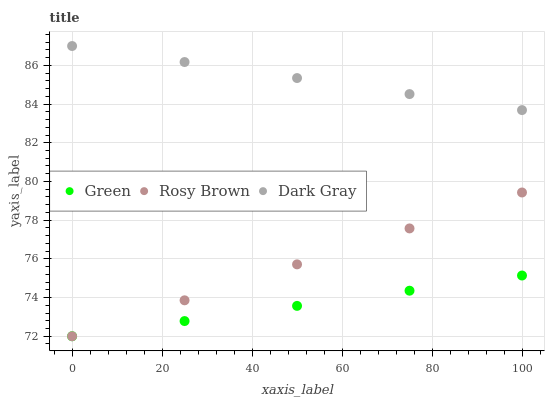Does Green have the minimum area under the curve?
Answer yes or no. Yes. Does Dark Gray have the maximum area under the curve?
Answer yes or no. Yes. Does Rosy Brown have the minimum area under the curve?
Answer yes or no. No. Does Rosy Brown have the maximum area under the curve?
Answer yes or no. No. Is Dark Gray the smoothest?
Answer yes or no. Yes. Is Rosy Brown the roughest?
Answer yes or no. Yes. Is Rosy Brown the smoothest?
Answer yes or no. No. Is Green the roughest?
Answer yes or no. No. Does Rosy Brown have the lowest value?
Answer yes or no. Yes. Does Dark Gray have the highest value?
Answer yes or no. Yes. Does Rosy Brown have the highest value?
Answer yes or no. No. Is Green less than Dark Gray?
Answer yes or no. Yes. Is Dark Gray greater than Green?
Answer yes or no. Yes. Does Rosy Brown intersect Green?
Answer yes or no. Yes. Is Rosy Brown less than Green?
Answer yes or no. No. Is Rosy Brown greater than Green?
Answer yes or no. No. Does Green intersect Dark Gray?
Answer yes or no. No. 